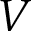Convert formula to latex. <formula><loc_0><loc_0><loc_500><loc_500>V</formula> 